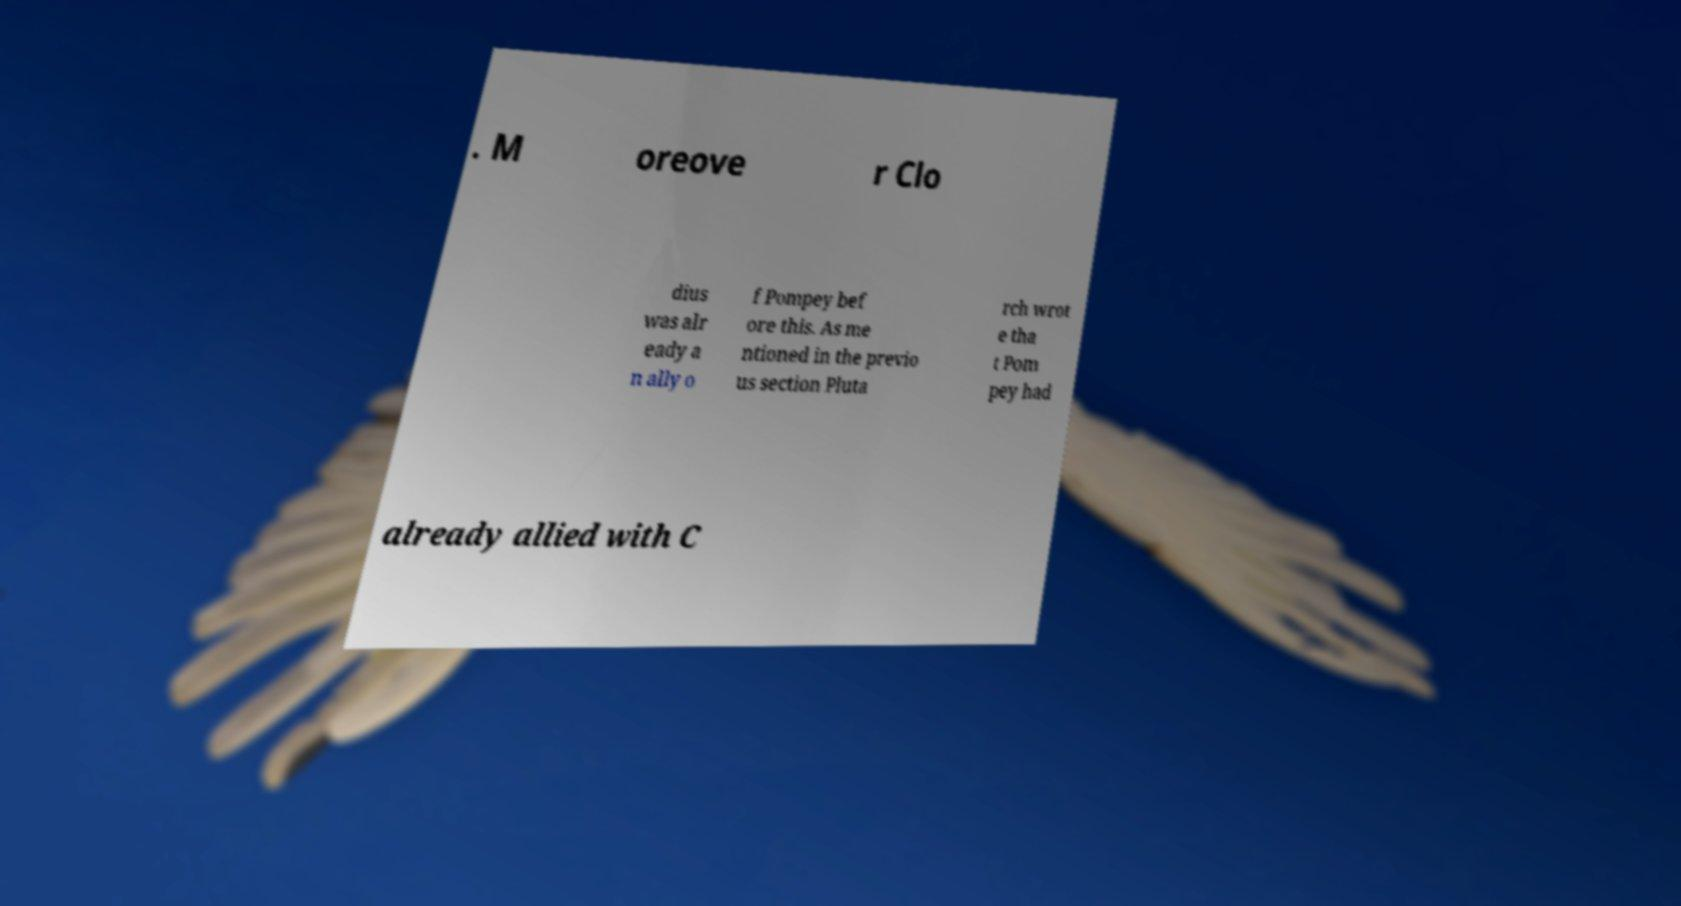Can you read and provide the text displayed in the image?This photo seems to have some interesting text. Can you extract and type it out for me? . M oreove r Clo dius was alr eady a n ally o f Pompey bef ore this. As me ntioned in the previo us section Pluta rch wrot e tha t Pom pey had already allied with C 